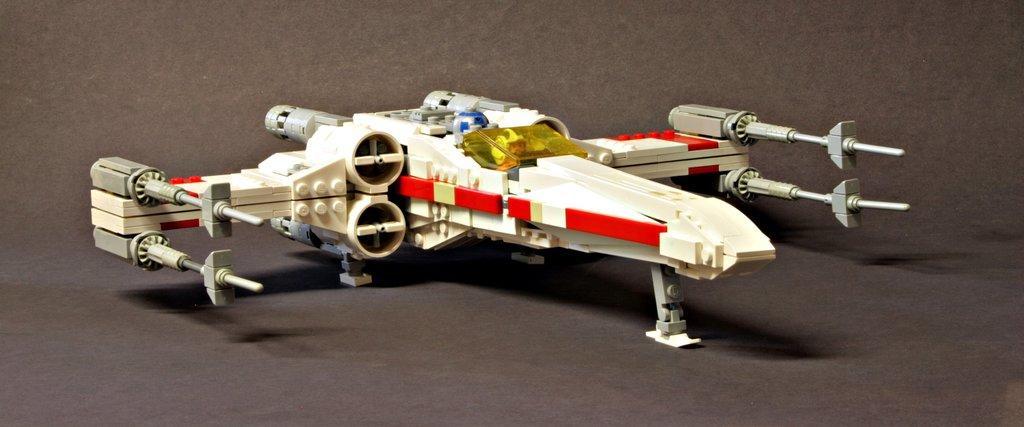Describe this image in one or two sentences. In this image I can see the miniature of the aircraft. The aircraft is in white, red and ash color. It is on the black color surface. 